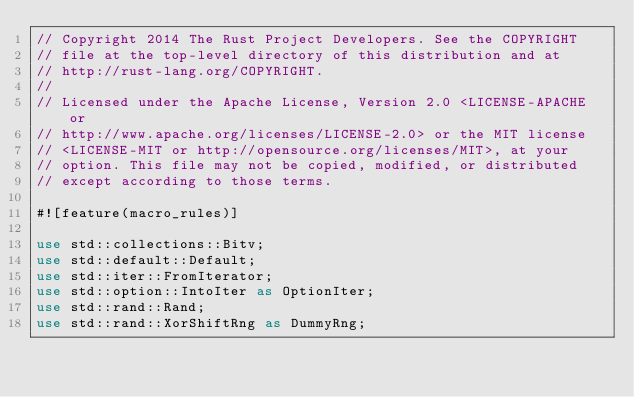Convert code to text. <code><loc_0><loc_0><loc_500><loc_500><_Rust_>// Copyright 2014 The Rust Project Developers. See the COPYRIGHT
// file at the top-level directory of this distribution and at
// http://rust-lang.org/COPYRIGHT.
//
// Licensed under the Apache License, Version 2.0 <LICENSE-APACHE or
// http://www.apache.org/licenses/LICENSE-2.0> or the MIT license
// <LICENSE-MIT or http://opensource.org/licenses/MIT>, at your
// option. This file may not be copied, modified, or distributed
// except according to those terms.

#![feature(macro_rules)]

use std::collections::Bitv;
use std::default::Default;
use std::iter::FromIterator;
use std::option::IntoIter as OptionIter;
use std::rand::Rand;
use std::rand::XorShiftRng as DummyRng;</code> 